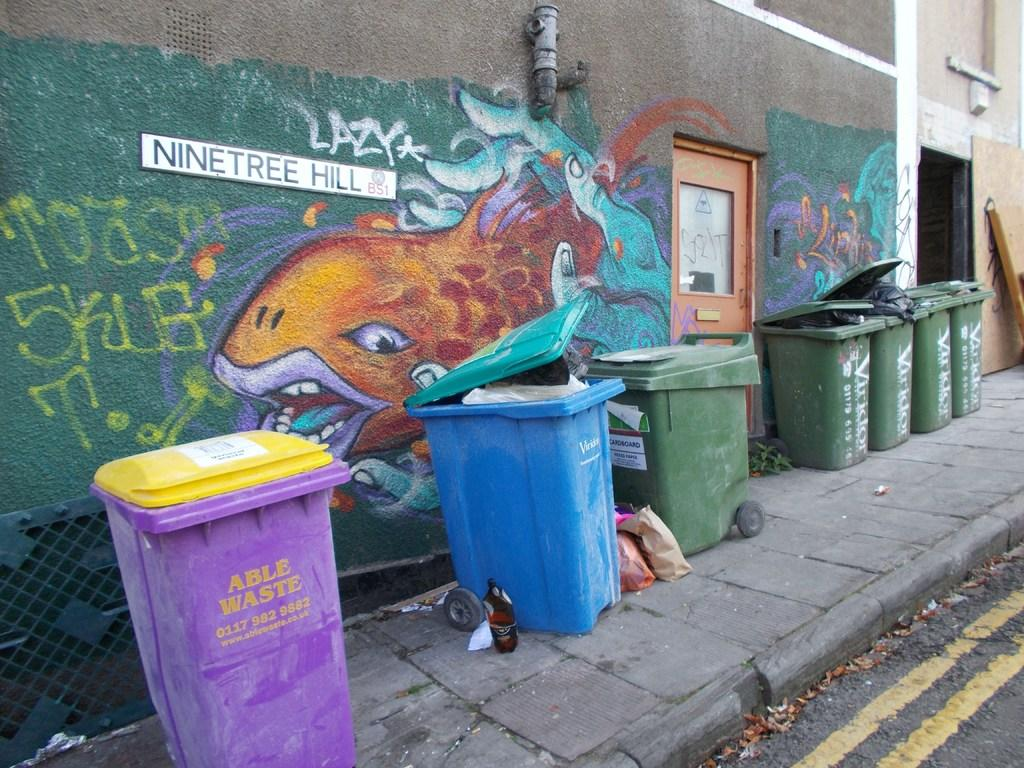<image>
Render a clear and concise summary of the photo. Purple Able Waste trashcan next to a row of other trashcans in an alley. 